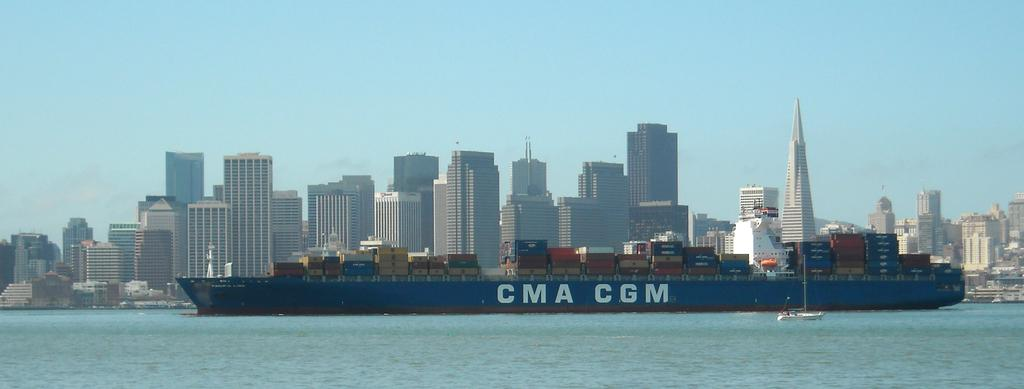What is present in the image that is related to water? There is water in the image. What type of water vehicle can be seen in the image? There is a boat in the image. What is the color of the huge ship in the image? The ship is blue in color. Where is the ship located in relation to the water? The ship is on the surface of the water. What can be seen in the background of the image? There are buildings and the sky visible in the background of the image. How many nails are used to hold the boat together in the image? There is no information about nails or the boat's construction in the image. What type of operation is being performed on the ship in the image? There is no operation or any indication of one being performed on the ship in the image. 